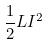Convert formula to latex. <formula><loc_0><loc_0><loc_500><loc_500>\frac { 1 } { 2 } L I ^ { 2 }</formula> 